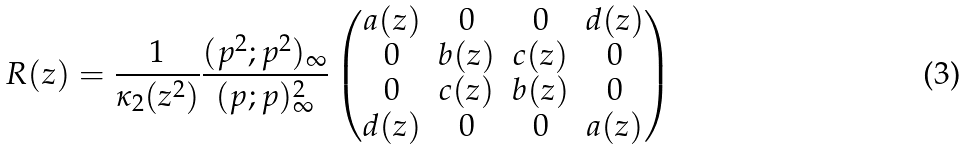Convert formula to latex. <formula><loc_0><loc_0><loc_500><loc_500>R ( z ) = \frac { 1 } { \kappa _ { 2 } ( z ^ { 2 } ) } \frac { ( p ^ { 2 } ; p ^ { 2 } ) _ { \infty } } { ( p ; p ) ^ { 2 } _ { \infty } } \begin{pmatrix} a ( z ) & 0 & 0 & d ( z ) \\ 0 & b ( z ) & c ( z ) & 0 \\ 0 & c ( z ) & b ( z ) & 0 \\ d ( z ) & 0 & 0 & a ( z ) \end{pmatrix}</formula> 